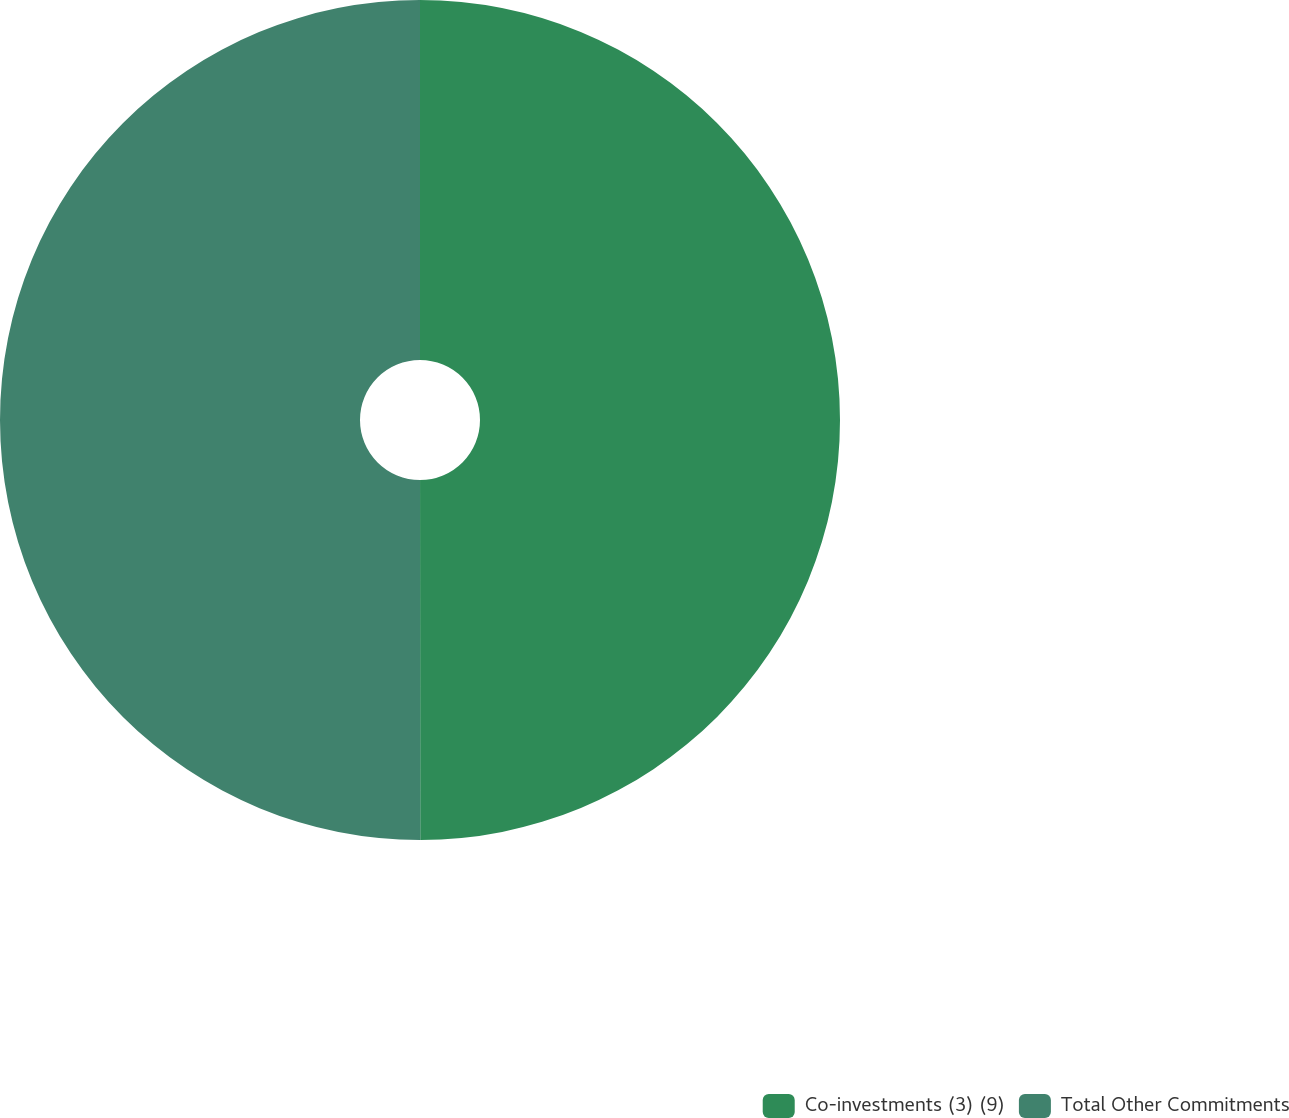Convert chart to OTSL. <chart><loc_0><loc_0><loc_500><loc_500><pie_chart><fcel>Co-investments (3) (9)<fcel>Total Other Commitments<nl><fcel>49.99%<fcel>50.01%<nl></chart> 